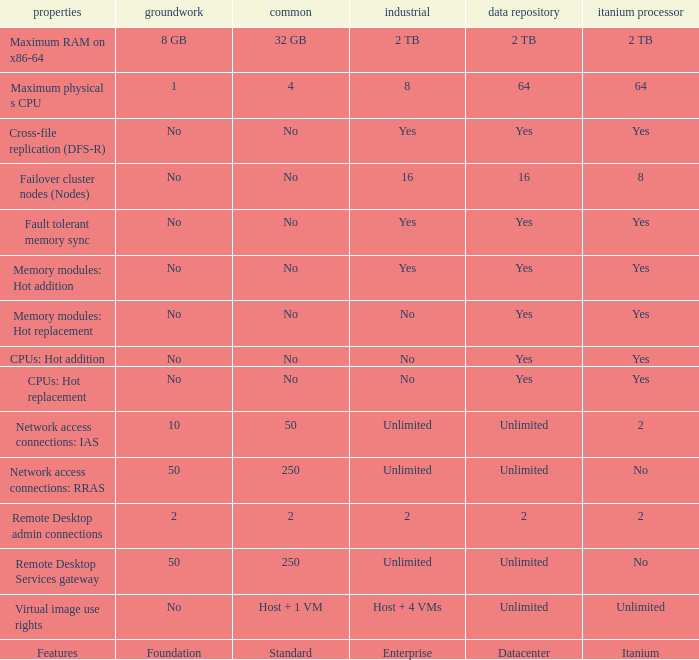Which Features have Yes listed under Datacenter? Cross-file replication (DFS-R), Fault tolerant memory sync, Memory modules: Hot addition, Memory modules: Hot replacement, CPUs: Hot addition, CPUs: Hot replacement. 